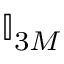<formula> <loc_0><loc_0><loc_500><loc_500>\mathbb { I } _ { 3 M }</formula> 